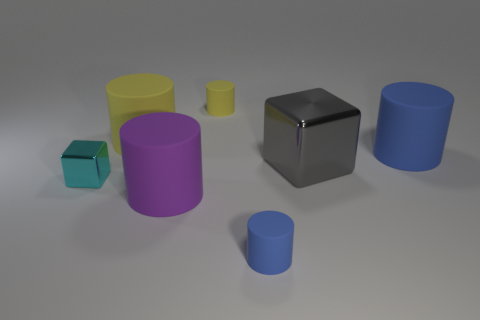Subtract all yellow rubber cylinders. How many cylinders are left? 3 Subtract all yellow cylinders. How many cylinders are left? 3 Subtract all cylinders. How many objects are left? 2 Subtract 2 blocks. How many blocks are left? 0 Subtract 0 gray spheres. How many objects are left? 7 Subtract all purple cylinders. Subtract all gray cubes. How many cylinders are left? 4 Subtract all red cylinders. How many blue cubes are left? 0 Subtract all tiny brown rubber spheres. Subtract all large blue cylinders. How many objects are left? 6 Add 3 large purple rubber objects. How many large purple rubber objects are left? 4 Add 1 big brown metal things. How many big brown metal things exist? 1 